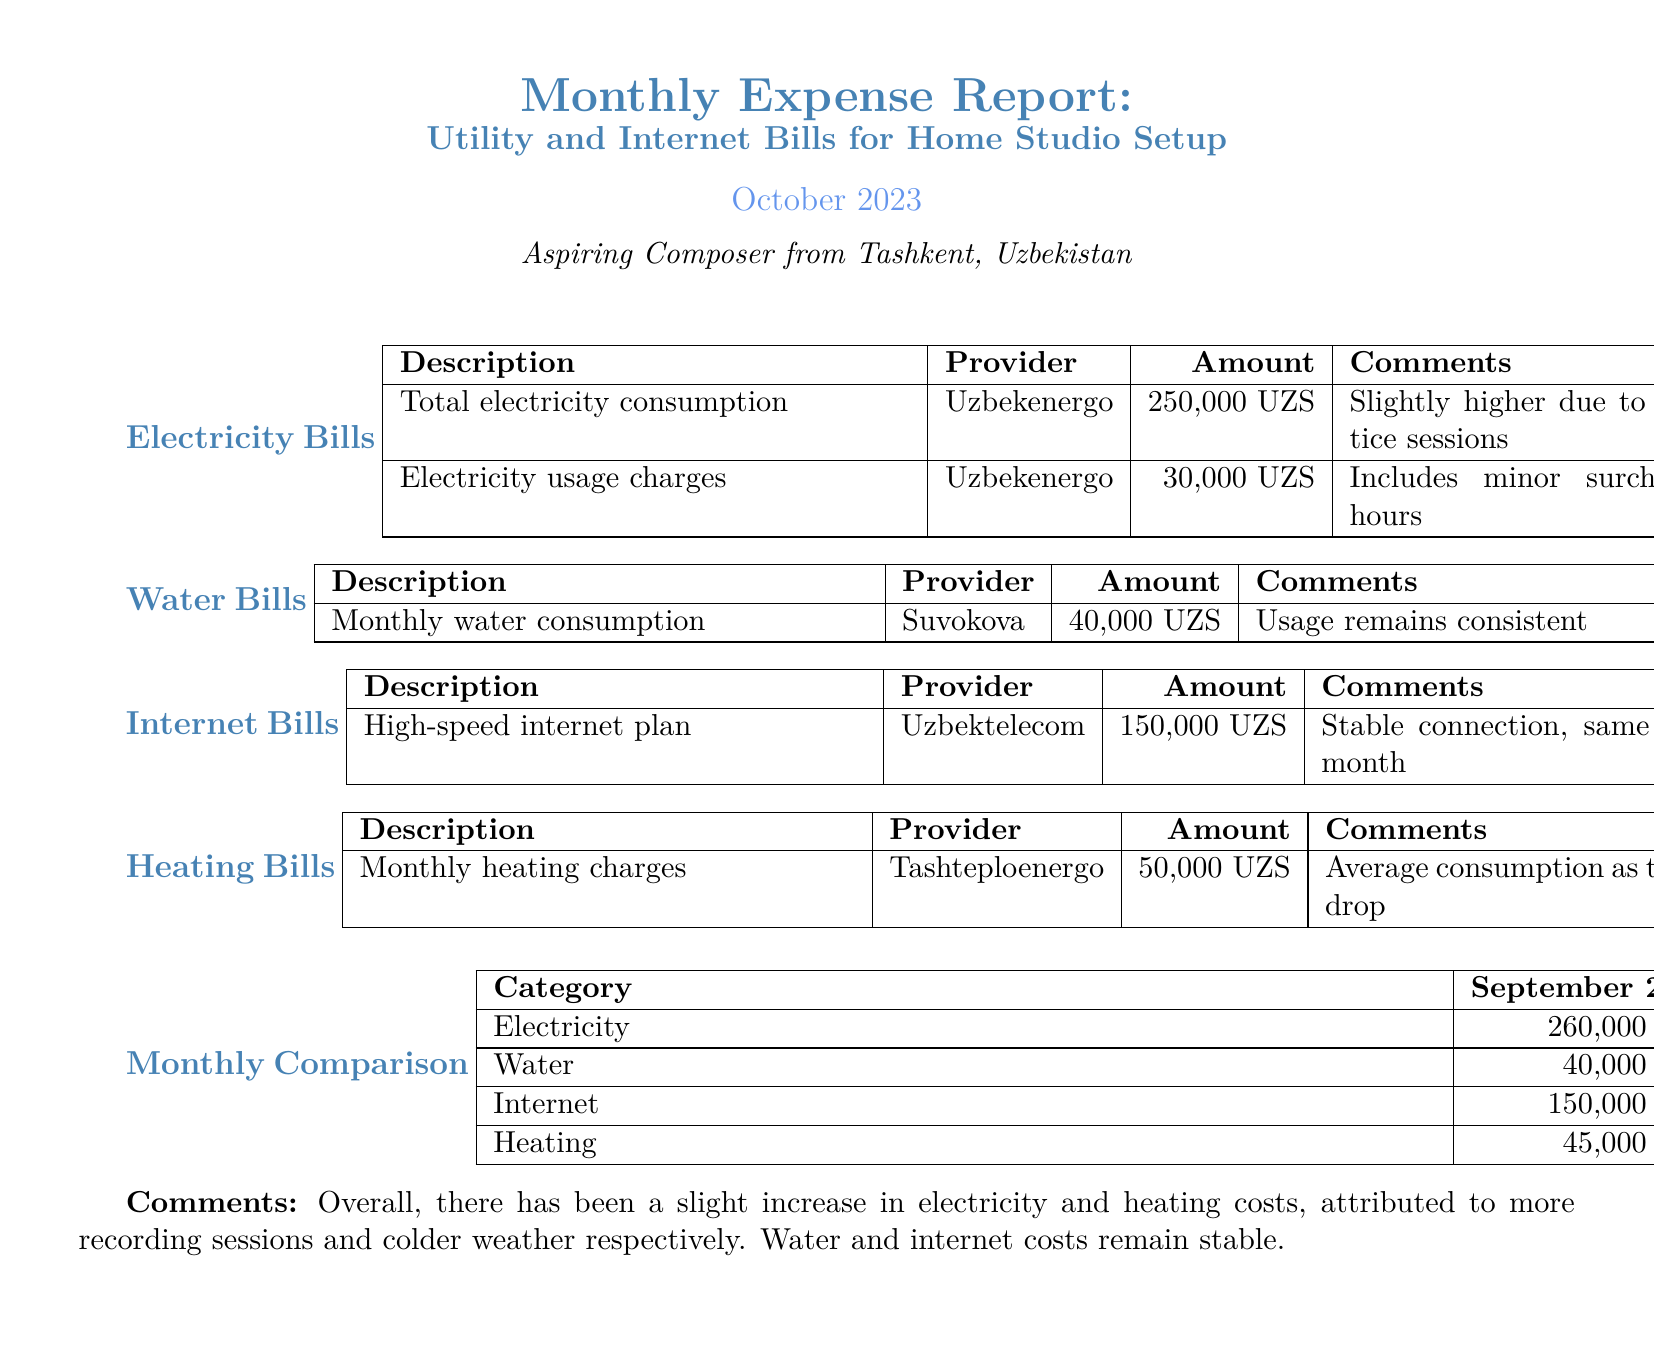what is the total electricity consumption for October 2023? The total electricity consumption for October 2023 is listed under electricity bills in the document.
Answer: 250,000 UZS who is the provider for the high-speed internet plan? The provider for the high-speed internet plan is mentioned in the Internet Bills section of the document.
Answer: Uzbektelecom how much did the water bills amount to in October 2023? The amount for the water bills in October 2023 can be found in the Water Bills section of the document.
Answer: 40,000 UZS what was the heating charge in September 2023? The heating charge for September 2023 is shown in the Monthly Comparison table which tracks changes over the months.
Answer: 45,000 UZS which category saw an increase in costs from September 2023 to October 2023? The Monthly Comparison section outlines the changes between the two months, highlighting which categories increased.
Answer: Electricity, Heating what is the amount charged for monthly heating in October 2023? The amount charged for monthly heating in October 2023 is specified in the Heating Bills section of the document.
Answer: 50,000 UZS did the internet bill change from September 2023 to October 2023? The Monthly Comparison section provides a direct comparison of the internet costs between the two months.
Answer: No 